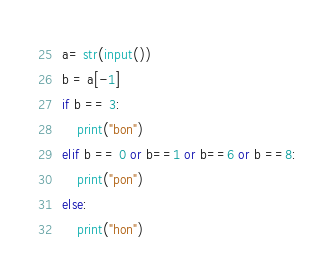Convert code to text. <code><loc_0><loc_0><loc_500><loc_500><_Python_>a= str(input())
b = a[-1]
if b == 3:
    print("bon")
elif b == 0 or b==1 or b==6 or b ==8:
    print("pon")
else:
    print("hon")
</code> 